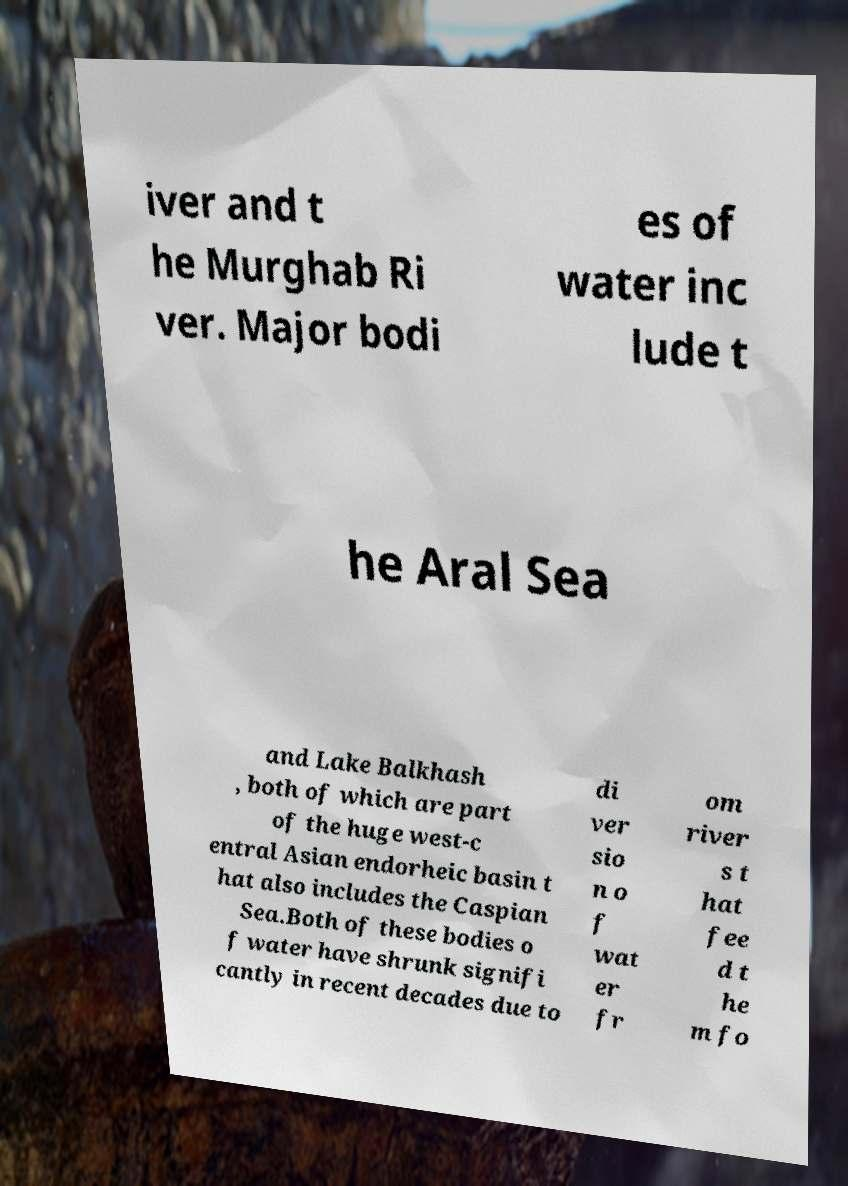Please read and relay the text visible in this image. What does it say? iver and t he Murghab Ri ver. Major bodi es of water inc lude t he Aral Sea and Lake Balkhash , both of which are part of the huge west-c entral Asian endorheic basin t hat also includes the Caspian Sea.Both of these bodies o f water have shrunk signifi cantly in recent decades due to di ver sio n o f wat er fr om river s t hat fee d t he m fo 